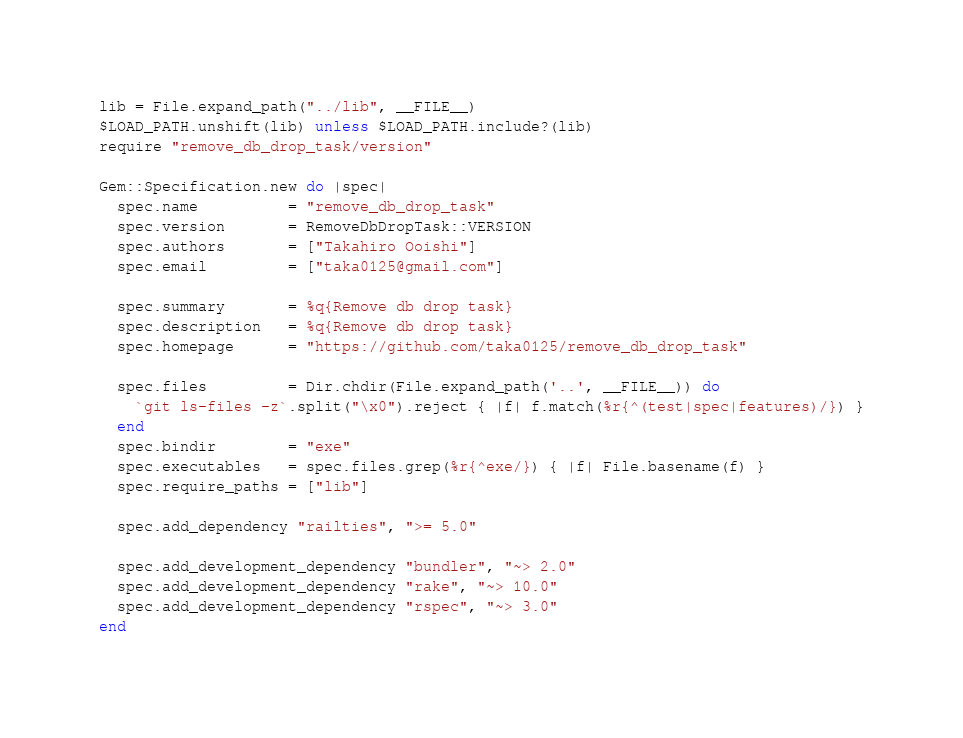Convert code to text. <code><loc_0><loc_0><loc_500><loc_500><_Ruby_>
lib = File.expand_path("../lib", __FILE__)
$LOAD_PATH.unshift(lib) unless $LOAD_PATH.include?(lib)
require "remove_db_drop_task/version"

Gem::Specification.new do |spec|
  spec.name          = "remove_db_drop_task"
  spec.version       = RemoveDbDropTask::VERSION
  spec.authors       = ["Takahiro Ooishi"]
  spec.email         = ["taka0125@gmail.com"]

  spec.summary       = %q{Remove db drop task}
  spec.description   = %q{Remove db drop task}
  spec.homepage      = "https://github.com/taka0125/remove_db_drop_task"

  spec.files         = Dir.chdir(File.expand_path('..', __FILE__)) do
    `git ls-files -z`.split("\x0").reject { |f| f.match(%r{^(test|spec|features)/}) }
  end
  spec.bindir        = "exe"
  spec.executables   = spec.files.grep(%r{^exe/}) { |f| File.basename(f) }
  spec.require_paths = ["lib"]

  spec.add_dependency "railties", ">= 5.0"

  spec.add_development_dependency "bundler", "~> 2.0"
  spec.add_development_dependency "rake", "~> 10.0"
  spec.add_development_dependency "rspec", "~> 3.0"
end
</code> 